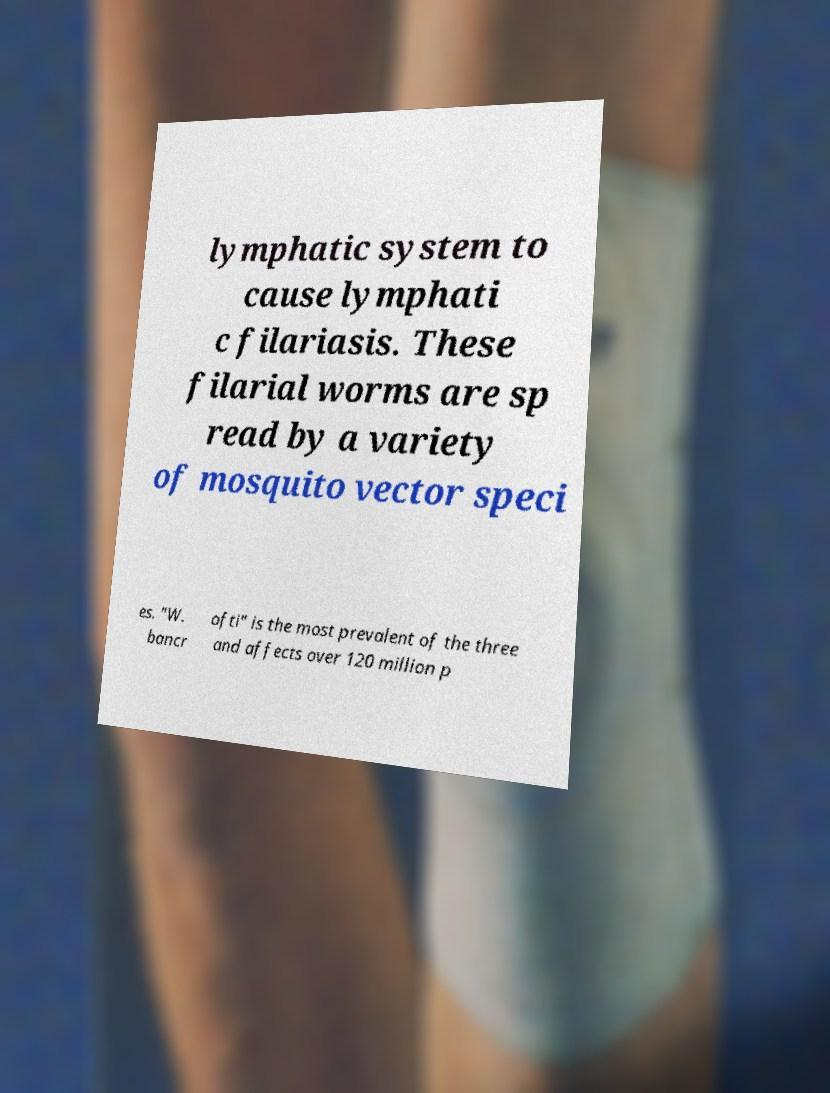What messages or text are displayed in this image? I need them in a readable, typed format. lymphatic system to cause lymphati c filariasis. These filarial worms are sp read by a variety of mosquito vector speci es. "W. bancr ofti" is the most prevalent of the three and affects over 120 million p 